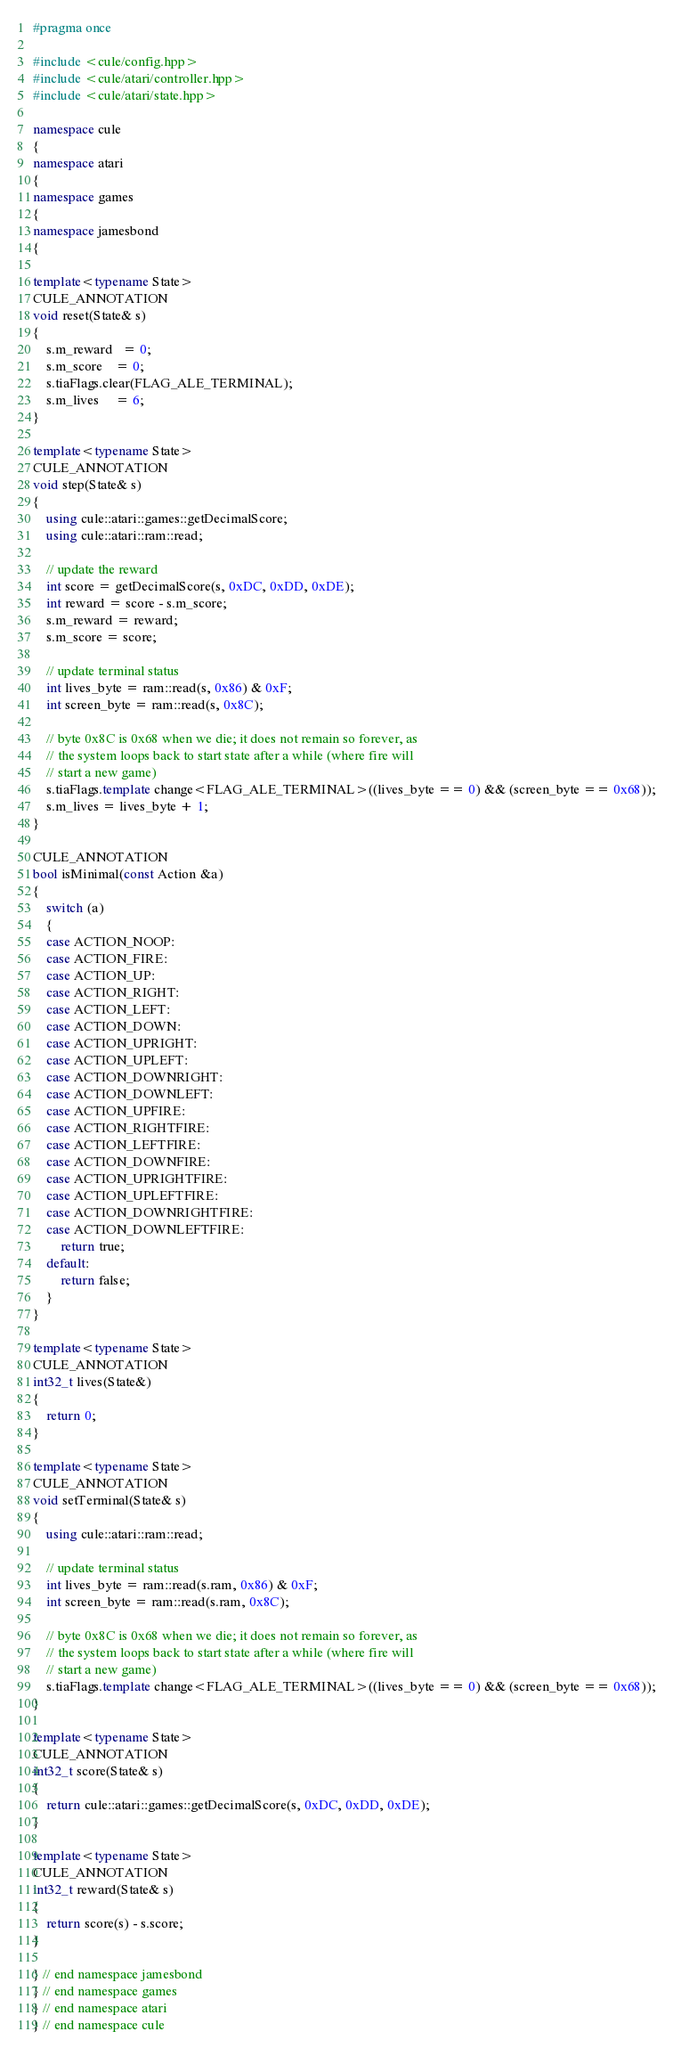<code> <loc_0><loc_0><loc_500><loc_500><_C++_>#pragma once

#include <cule/config.hpp>
#include <cule/atari/controller.hpp>
#include <cule/atari/state.hpp>

namespace cule
{
namespace atari
{
namespace games
{
namespace jamesbond
{

template<typename State>
CULE_ANNOTATION
void reset(State& s)
{
    s.m_reward   = 0;
    s.m_score    = 0;
    s.tiaFlags.clear(FLAG_ALE_TERMINAL);
    s.m_lives 	 = 6;
}

template<typename State>
CULE_ANNOTATION
void step(State& s)
{
    using cule::atari::games::getDecimalScore;
    using cule::atari::ram::read;

    // update the reward
    int score = getDecimalScore(s, 0xDC, 0xDD, 0xDE);
    int reward = score - s.m_score;
    s.m_reward = reward;
    s.m_score = score;

    // update terminal status
    int lives_byte = ram::read(s, 0x86) & 0xF;
    int screen_byte = ram::read(s, 0x8C);

    // byte 0x8C is 0x68 when we die; it does not remain so forever, as
    // the system loops back to start state after a while (where fire will
    // start a new game)
    s.tiaFlags.template change<FLAG_ALE_TERMINAL>((lives_byte == 0) && (screen_byte == 0x68));
    s.m_lives = lives_byte + 1;
}

CULE_ANNOTATION
bool isMinimal(const Action &a)
{
    switch (a)
    {
    case ACTION_NOOP:
    case ACTION_FIRE:
    case ACTION_UP:
    case ACTION_RIGHT:
    case ACTION_LEFT:
    case ACTION_DOWN:
    case ACTION_UPRIGHT:
    case ACTION_UPLEFT:
    case ACTION_DOWNRIGHT:
    case ACTION_DOWNLEFT:
    case ACTION_UPFIRE:
    case ACTION_RIGHTFIRE:
    case ACTION_LEFTFIRE:
    case ACTION_DOWNFIRE:
    case ACTION_UPRIGHTFIRE:
    case ACTION_UPLEFTFIRE:
    case ACTION_DOWNRIGHTFIRE:
    case ACTION_DOWNLEFTFIRE:
        return true;
    default:
        return false;
    }
}

template<typename State>
CULE_ANNOTATION
int32_t lives(State&)
{
    return 0;
}

template<typename State>
CULE_ANNOTATION
void setTerminal(State& s)
{
    using cule::atari::ram::read;

    // update terminal status
    int lives_byte = ram::read(s.ram, 0x86) & 0xF;
    int screen_byte = ram::read(s.ram, 0x8C);

    // byte 0x8C is 0x68 when we die; it does not remain so forever, as
    // the system loops back to start state after a while (where fire will
    // start a new game)
    s.tiaFlags.template change<FLAG_ALE_TERMINAL>((lives_byte == 0) && (screen_byte == 0x68));
}

template<typename State>
CULE_ANNOTATION
int32_t score(State& s)
{
    return cule::atari::games::getDecimalScore(s, 0xDC, 0xDD, 0xDE);
}

template<typename State>
CULE_ANNOTATION
int32_t reward(State& s)
{
    return score(s) - s.score;
}

} // end namespace jamesbond
} // end namespace games
} // end namespace atari
} // end namespace cule

</code> 